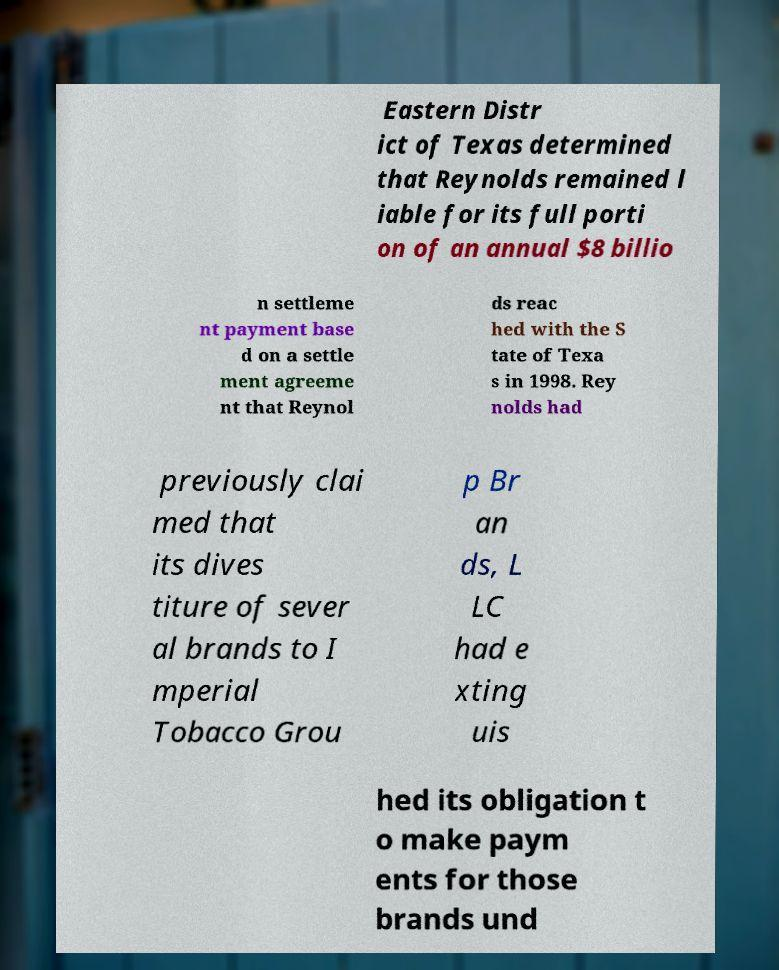I need the written content from this picture converted into text. Can you do that? Eastern Distr ict of Texas determined that Reynolds remained l iable for its full porti on of an annual $8 billio n settleme nt payment base d on a settle ment agreeme nt that Reynol ds reac hed with the S tate of Texa s in 1998. Rey nolds had previously clai med that its dives titure of sever al brands to I mperial Tobacco Grou p Br an ds, L LC had e xting uis hed its obligation t o make paym ents for those brands und 